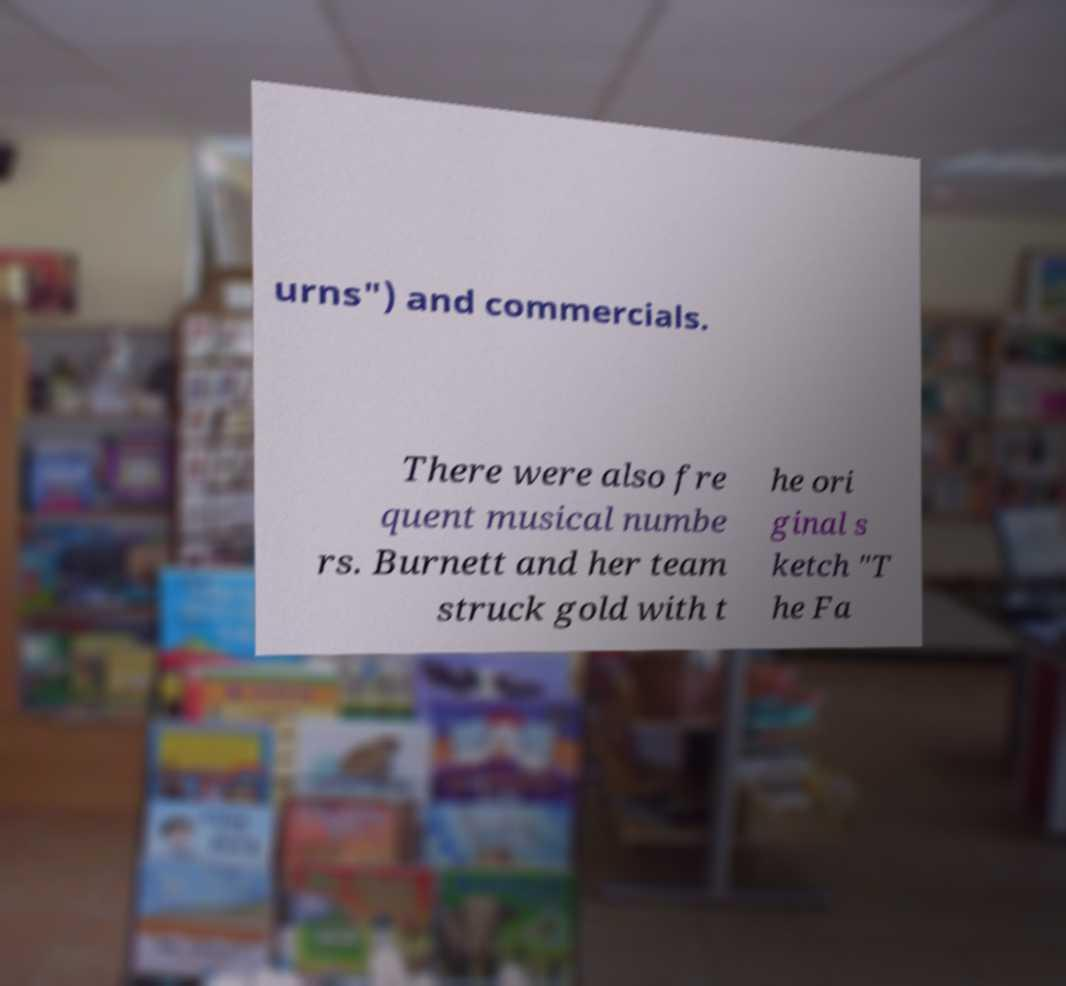I need the written content from this picture converted into text. Can you do that? urns") and commercials. There were also fre quent musical numbe rs. Burnett and her team struck gold with t he ori ginal s ketch "T he Fa 